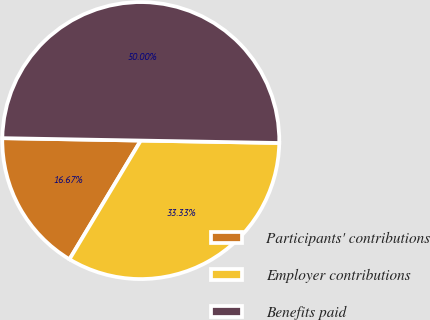<chart> <loc_0><loc_0><loc_500><loc_500><pie_chart><fcel>Participants' contributions<fcel>Employer contributions<fcel>Benefits paid<nl><fcel>16.67%<fcel>33.33%<fcel>50.0%<nl></chart> 